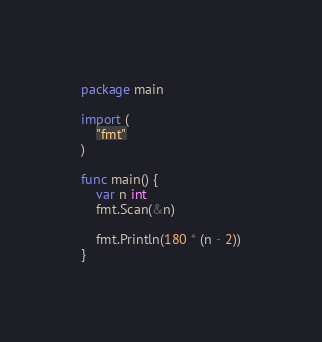<code> <loc_0><loc_0><loc_500><loc_500><_Go_>package main

import (
	"fmt"
)

func main() {
	var n int
	fmt.Scan(&n)

	fmt.Println(180 * (n - 2))
}
</code> 